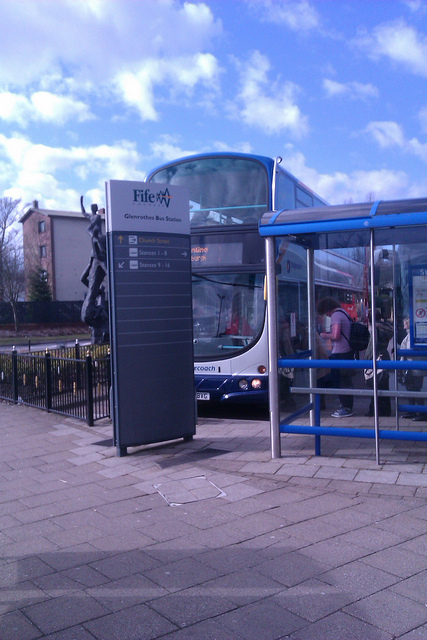Read all the text in this image. FIFE 